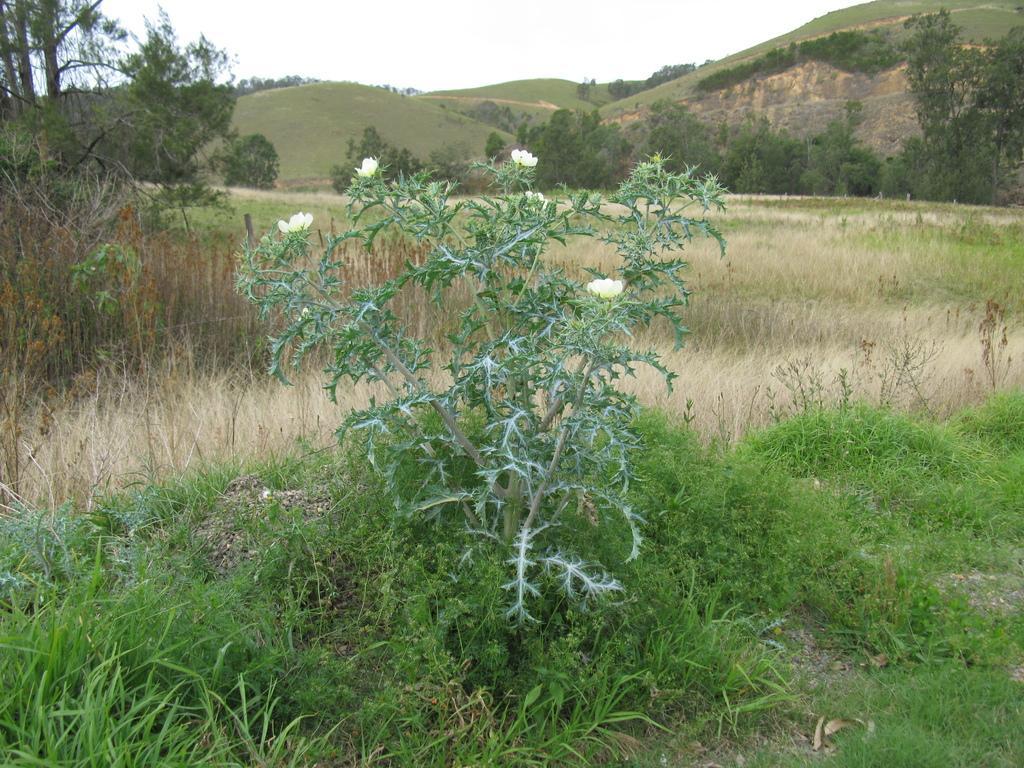Please provide a concise description of this image. In this image we can see a plant with flowers and grass on the ground. In the background we can see grass, trees, hills and the sky. 